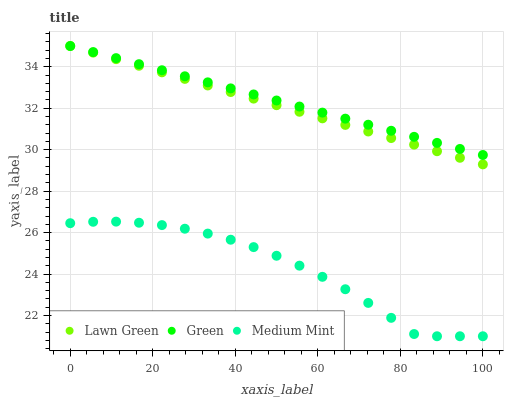Does Medium Mint have the minimum area under the curve?
Answer yes or no. Yes. Does Green have the maximum area under the curve?
Answer yes or no. Yes. Does Lawn Green have the minimum area under the curve?
Answer yes or no. No. Does Lawn Green have the maximum area under the curve?
Answer yes or no. No. Is Green the smoothest?
Answer yes or no. Yes. Is Medium Mint the roughest?
Answer yes or no. Yes. Is Lawn Green the smoothest?
Answer yes or no. No. Is Lawn Green the roughest?
Answer yes or no. No. Does Medium Mint have the lowest value?
Answer yes or no. Yes. Does Lawn Green have the lowest value?
Answer yes or no. No. Does Green have the highest value?
Answer yes or no. Yes. Is Medium Mint less than Lawn Green?
Answer yes or no. Yes. Is Green greater than Medium Mint?
Answer yes or no. Yes. Does Green intersect Lawn Green?
Answer yes or no. Yes. Is Green less than Lawn Green?
Answer yes or no. No. Is Green greater than Lawn Green?
Answer yes or no. No. Does Medium Mint intersect Lawn Green?
Answer yes or no. No. 